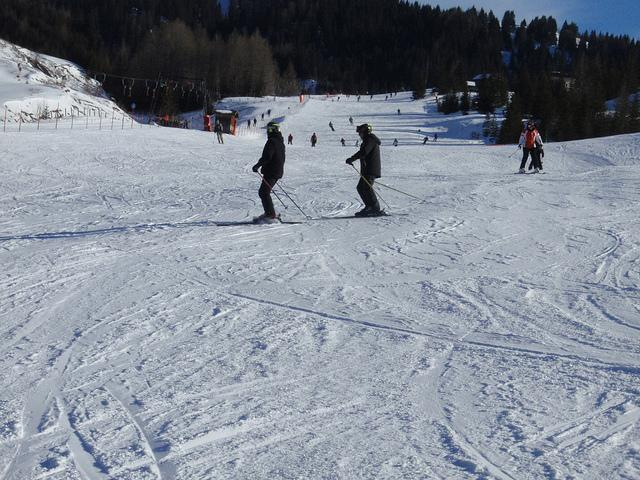Where can you most likely catch a ride nearby? ski lift 